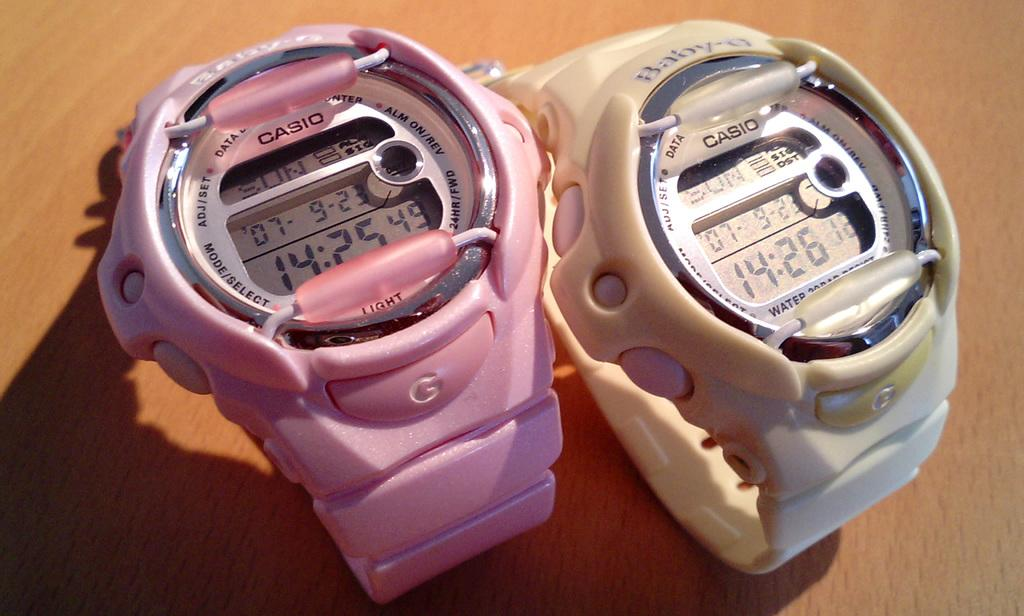<image>
Share a concise interpretation of the image provided. two casio watches, pink and white are side by side on a table 